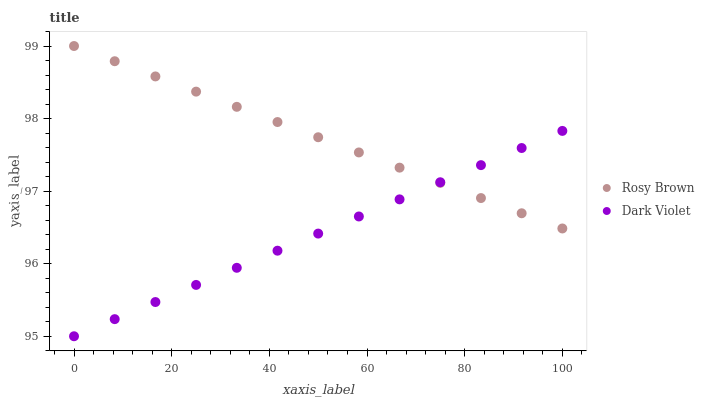Does Dark Violet have the minimum area under the curve?
Answer yes or no. Yes. Does Rosy Brown have the maximum area under the curve?
Answer yes or no. Yes. Does Dark Violet have the maximum area under the curve?
Answer yes or no. No. Is Rosy Brown the smoothest?
Answer yes or no. Yes. Is Dark Violet the roughest?
Answer yes or no. Yes. Is Dark Violet the smoothest?
Answer yes or no. No. Does Dark Violet have the lowest value?
Answer yes or no. Yes. Does Rosy Brown have the highest value?
Answer yes or no. Yes. Does Dark Violet have the highest value?
Answer yes or no. No. Does Dark Violet intersect Rosy Brown?
Answer yes or no. Yes. Is Dark Violet less than Rosy Brown?
Answer yes or no. No. Is Dark Violet greater than Rosy Brown?
Answer yes or no. No. 